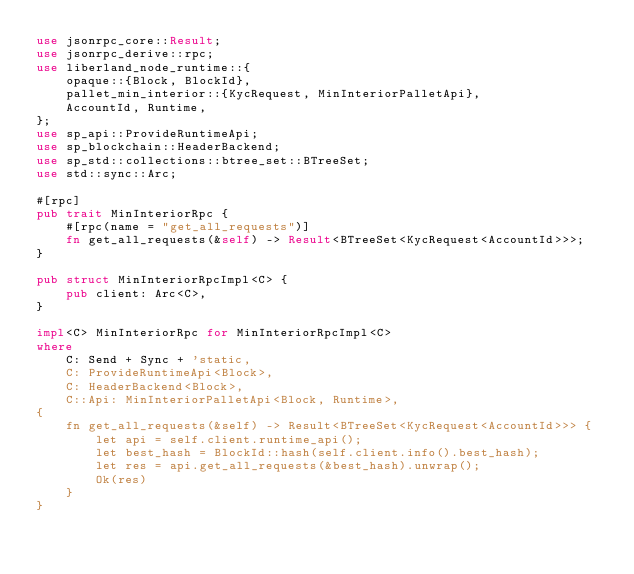<code> <loc_0><loc_0><loc_500><loc_500><_Rust_>use jsonrpc_core::Result;
use jsonrpc_derive::rpc;
use liberland_node_runtime::{
    opaque::{Block, BlockId},
    pallet_min_interior::{KycRequest, MinInteriorPalletApi},
    AccountId, Runtime,
};
use sp_api::ProvideRuntimeApi;
use sp_blockchain::HeaderBackend;
use sp_std::collections::btree_set::BTreeSet;
use std::sync::Arc;

#[rpc]
pub trait MinInteriorRpc {
    #[rpc(name = "get_all_requests")]
    fn get_all_requests(&self) -> Result<BTreeSet<KycRequest<AccountId>>>;
}

pub struct MinInteriorRpcImpl<C> {
    pub client: Arc<C>,
}

impl<C> MinInteriorRpc for MinInteriorRpcImpl<C>
where
    C: Send + Sync + 'static,
    C: ProvideRuntimeApi<Block>,
    C: HeaderBackend<Block>,
    C::Api: MinInteriorPalletApi<Block, Runtime>,
{
    fn get_all_requests(&self) -> Result<BTreeSet<KycRequest<AccountId>>> {
        let api = self.client.runtime_api();
        let best_hash = BlockId::hash(self.client.info().best_hash);
        let res = api.get_all_requests(&best_hash).unwrap();
        Ok(res)
    }
}
</code> 